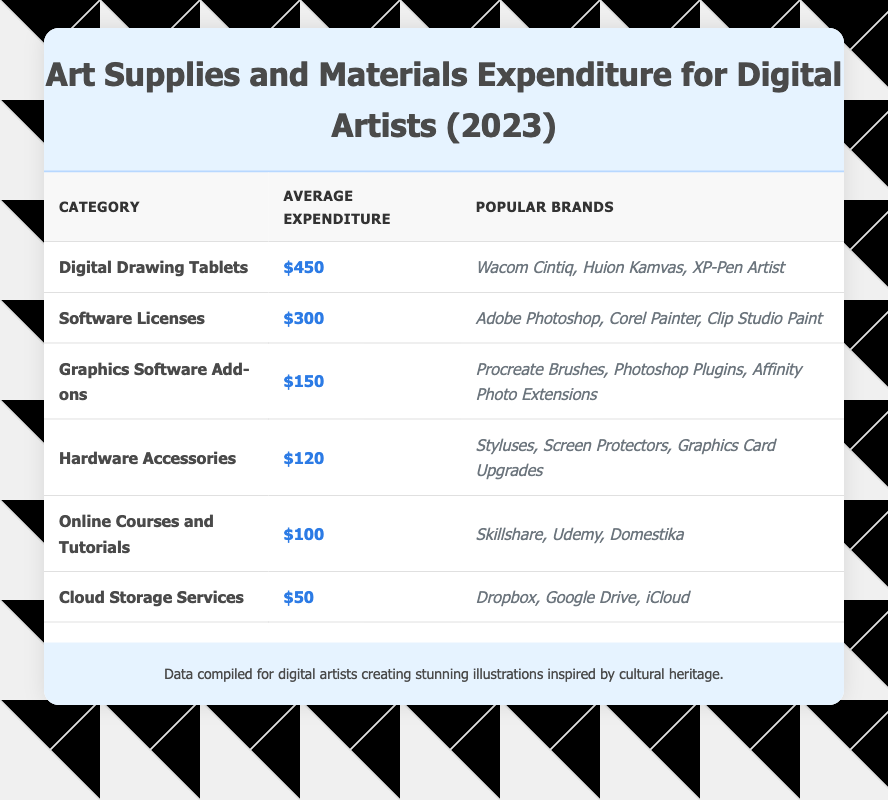What is the average expenditure on Digital Drawing Tablets? The table shows that the average expenditure for Digital Drawing Tablets is listed under the corresponding category. It is specified as $450.
Answer: $450 Which category has the lowest average expenditure? By comparing the average expenditure values listed in the table, it can be observed that Cloud Storage Services has the lowest average expenditure of $50.
Answer: Cloud Storage Services What is the total average expenditure for Hardware Accessories and Online Courses? To find this, first locate the average expenditures for each category: Hardware Accessories is $120 and Online Courses is $100. Then, sum these values: 120 + 100 = 220.
Answer: $220 Is Adobe Photoshop among the popular brands listed for Software Licenses? The table mentions the popular brands for Software Licenses, which include Adobe Photoshop, confirming that it is indeed one of the brands listed.
Answer: Yes If you add the average expenditures for Digital Drawing Tablets and Software Licenses, what is the result? The average expenditure for Digital Drawing Tablets is $450 and for Software Licenses it is $300. Adding these values together gives us: 450 + 300 = 750.
Answer: $750 What percentage of the total average expenditure does the average expenditure for Graphics Software Add-ons represent? First, sum the average expenditures for all categories: $450 + $300 + $150 + $120 + $100 + $50 = $1170. The average for Graphics Software Add-ons is $150. Now, calculate the percentage: (150 / 1170) * 100 ≈ 12.82%.
Answer: Approximately 12.82% How much more is spent on Software Licenses than on Cloud Storage Services? The average expenditure for Software Licenses is $300 and for Cloud Storage Services is $50. Subtract the Cloud Storage Services expenditure from the Software Licenses expenditure: 300 - 50 = 250.
Answer: $250 What is the combined average expenditure on all courses and tutorials? The table shows that Online Courses and Tutorials have an average expenditure of $100. Since there's only one such category, the combined average expenditure is simply $100.
Answer: $100 Which category has a higher average expenditure: Hardware Accessories or Graphics Software Add-ons? Looking at the table, Hardware Accessories has an average expenditure of $120 and Graphics Software Add-ons has $150. Since 150 is greater than 120, Graphics Software Add-ons has a higher average.
Answer: Graphics Software Add-ons If you consider the Digital Drawing Tablets and Hardware Accessories averages, what fraction of the total of these two categories does the average for Hardware Accessories represent? The average for Digital Drawing Tablets is $450 and for Hardware Accessories is $120. First, sum these averages: 450 + 120 = 570. Then, to find the fraction that Hardware Accessories represents: 120 / 570 simplifies to 2/9.
Answer: 2/9 